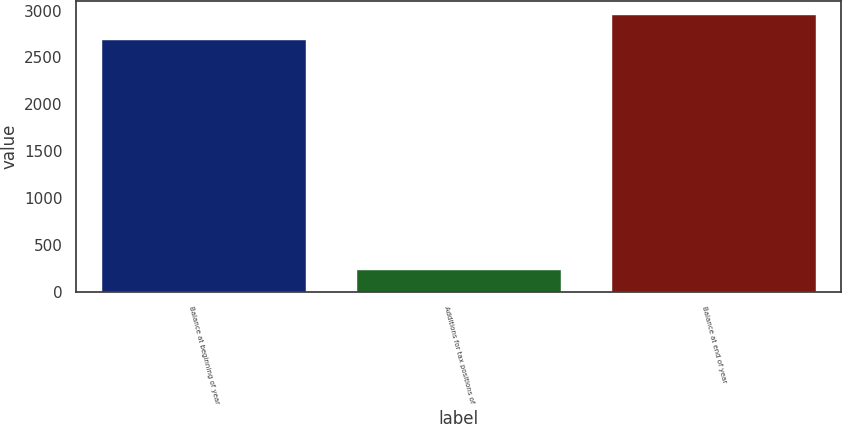<chart> <loc_0><loc_0><loc_500><loc_500><bar_chart><fcel>Balance at beginning of year<fcel>Additions for tax positions of<fcel>Balance at end of year<nl><fcel>2685<fcel>239<fcel>2953.5<nl></chart> 